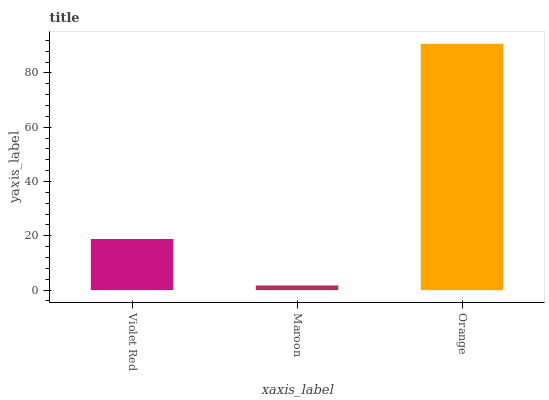Is Orange the minimum?
Answer yes or no. No. Is Maroon the maximum?
Answer yes or no. No. Is Orange greater than Maroon?
Answer yes or no. Yes. Is Maroon less than Orange?
Answer yes or no. Yes. Is Maroon greater than Orange?
Answer yes or no. No. Is Orange less than Maroon?
Answer yes or no. No. Is Violet Red the high median?
Answer yes or no. Yes. Is Violet Red the low median?
Answer yes or no. Yes. Is Orange the high median?
Answer yes or no. No. Is Orange the low median?
Answer yes or no. No. 